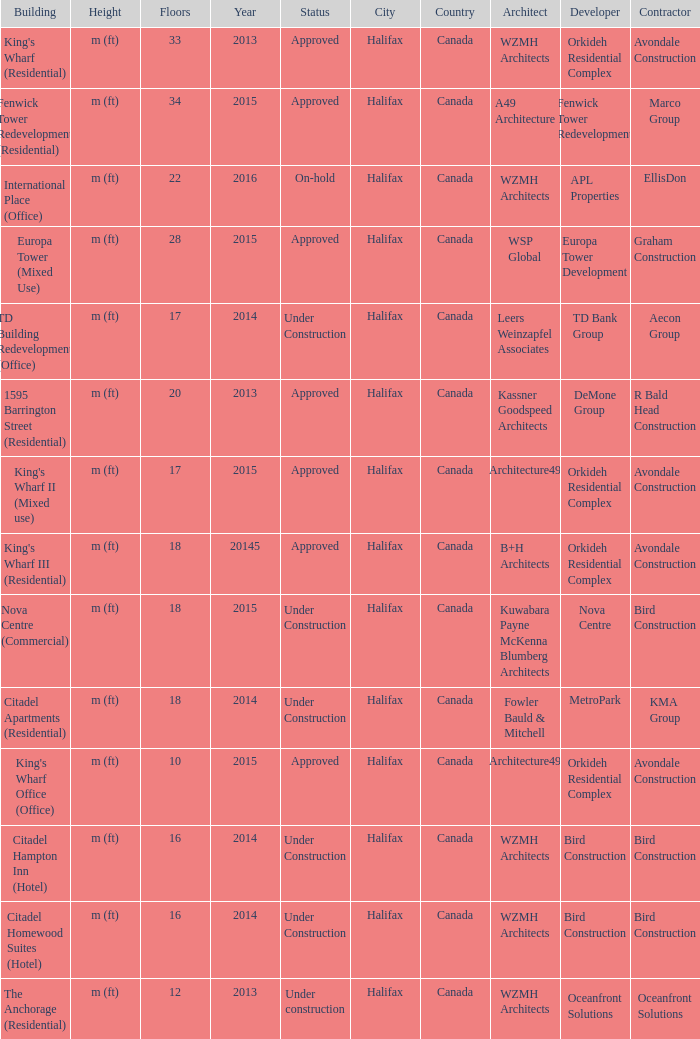What are the number of floors for the building of td building redevelopment (office)? 17.0. 